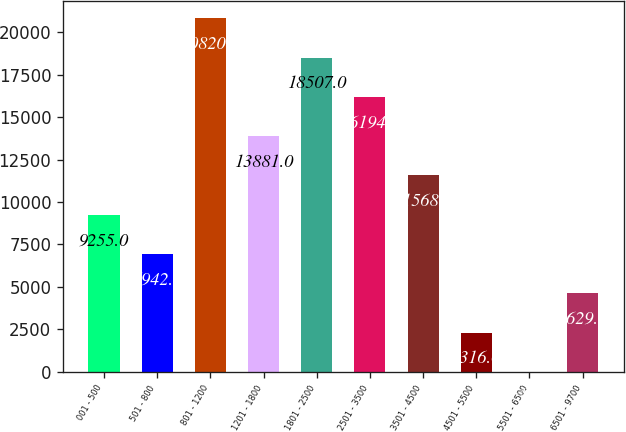<chart> <loc_0><loc_0><loc_500><loc_500><bar_chart><fcel>001 - 500<fcel>501 - 800<fcel>801 - 1200<fcel>1201 - 1800<fcel>1801 - 2500<fcel>2501 - 3500<fcel>3501 - 4500<fcel>4501 - 5500<fcel>5501 - 6500<fcel>6501 - 9700<nl><fcel>9255<fcel>6942<fcel>20820<fcel>13881<fcel>18507<fcel>16194<fcel>11568<fcel>2316<fcel>3<fcel>4629<nl></chart> 